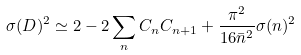<formula> <loc_0><loc_0><loc_500><loc_500>\sigma ( D ) ^ { 2 } \simeq 2 - 2 \sum _ { n } C _ { n } C _ { n + 1 } + \frac { \pi ^ { 2 } } { 1 6 \bar { n } ^ { 2 } } \sigma ( n ) ^ { 2 }</formula> 